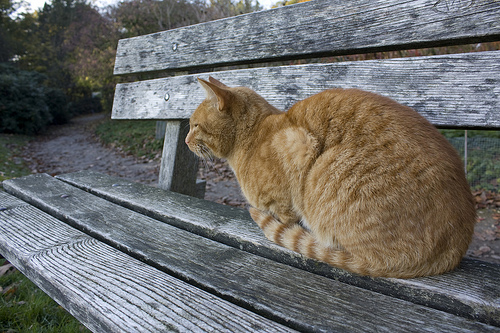Which kind of animal is gold? The cat on the bench is gold in color. 